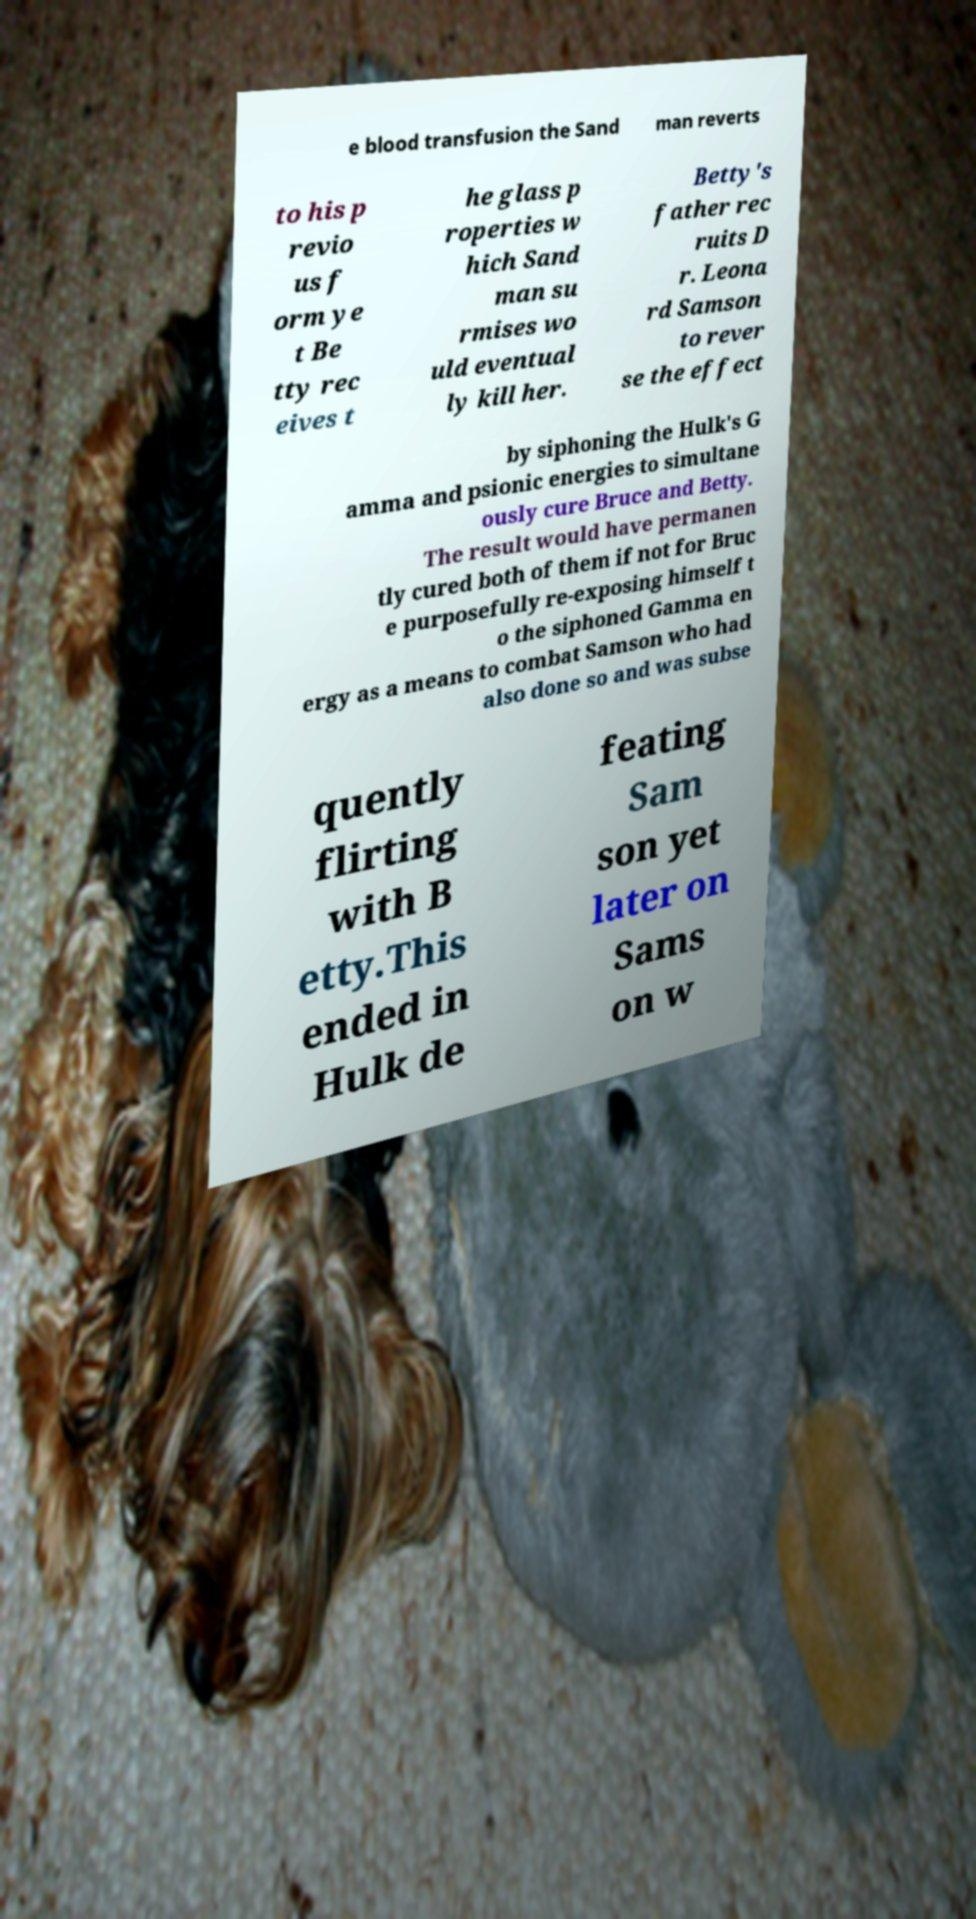Can you accurately transcribe the text from the provided image for me? e blood transfusion the Sand man reverts to his p revio us f orm ye t Be tty rec eives t he glass p roperties w hich Sand man su rmises wo uld eventual ly kill her. Betty's father rec ruits D r. Leona rd Samson to rever se the effect by siphoning the Hulk's G amma and psionic energies to simultane ously cure Bruce and Betty. The result would have permanen tly cured both of them if not for Bruc e purposefully re-exposing himself t o the siphoned Gamma en ergy as a means to combat Samson who had also done so and was subse quently flirting with B etty.This ended in Hulk de feating Sam son yet later on Sams on w 